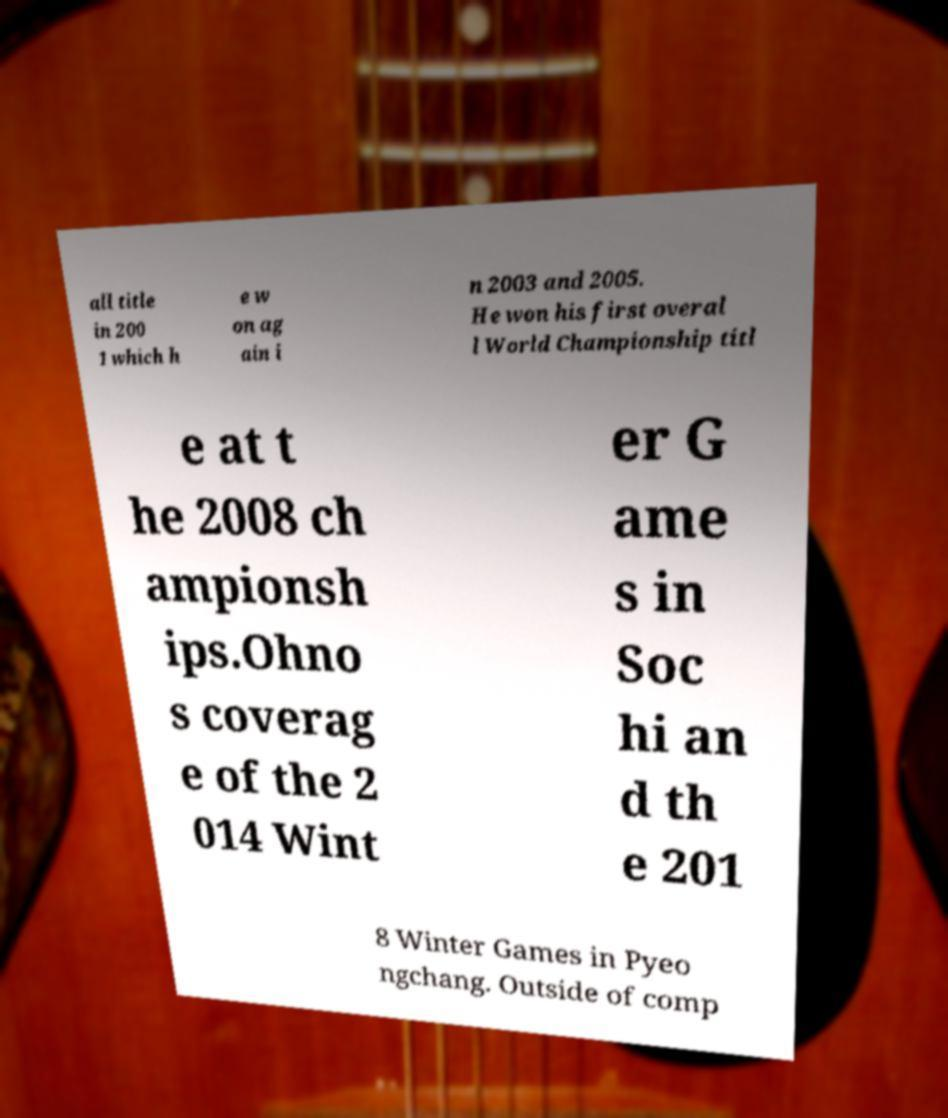Please read and relay the text visible in this image. What does it say? all title in 200 1 which h e w on ag ain i n 2003 and 2005. He won his first overal l World Championship titl e at t he 2008 ch ampionsh ips.Ohno s coverag e of the 2 014 Wint er G ame s in Soc hi an d th e 201 8 Winter Games in Pyeo ngchang. Outside of comp 